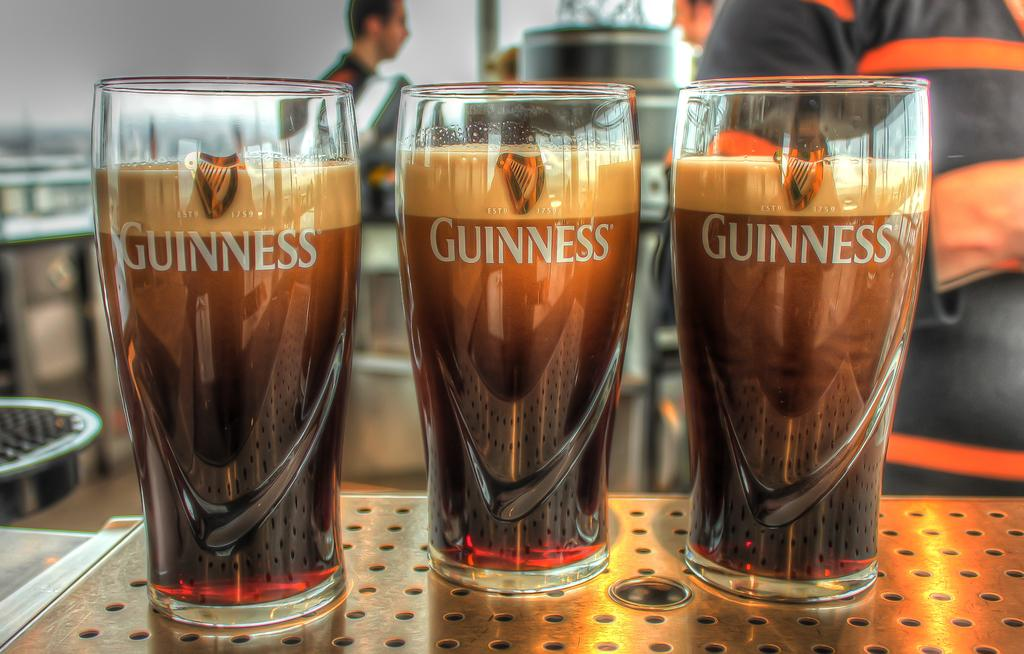Provide a one-sentence caption for the provided image. Three tall drinking glasses, with the word Guiness on each, filled with some type of beverage. 